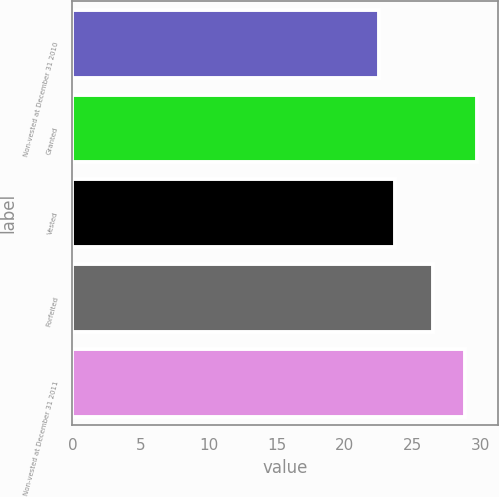<chart> <loc_0><loc_0><loc_500><loc_500><bar_chart><fcel>Non-vested at December 31 2010<fcel>Granted<fcel>Vested<fcel>Forfeited<fcel>Non-vested at December 31 2011<nl><fcel>22.53<fcel>29.77<fcel>23.69<fcel>26.53<fcel>28.85<nl></chart> 